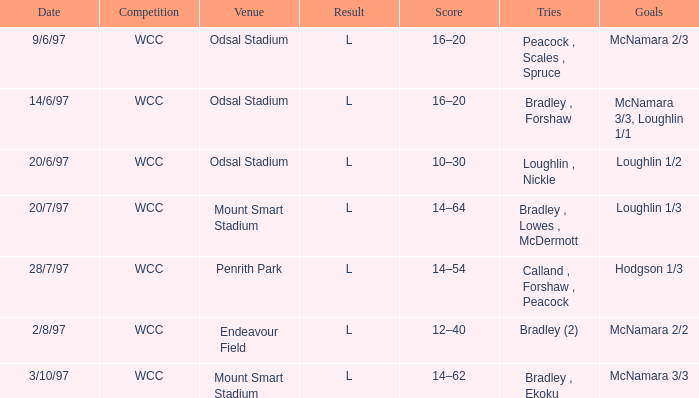Parse the table in full. {'header': ['Date', 'Competition', 'Venue', 'Result', 'Score', 'Tries', 'Goals'], 'rows': [['9/6/97', 'WCC', 'Odsal Stadium', 'L', '16–20', 'Peacock , Scales , Spruce', 'McNamara 2/3'], ['14/6/97', 'WCC', 'Odsal Stadium', 'L', '16–20', 'Bradley , Forshaw', 'McNamara 3/3, Loughlin 1/1'], ['20/6/97', 'WCC', 'Odsal Stadium', 'L', '10–30', 'Loughlin , Nickle', 'Loughlin 1/2'], ['20/7/97', 'WCC', 'Mount Smart Stadium', 'L', '14–64', 'Bradley , Lowes , McDermott', 'Loughlin 1/3'], ['28/7/97', 'WCC', 'Penrith Park', 'L', '14–54', 'Calland , Forshaw , Peacock', 'Hodgson 1/3'], ['2/8/97', 'WCC', 'Endeavour Field', 'L', '12–40', 'Bradley (2)', 'McNamara 2/2'], ['3/10/97', 'WCC', 'Mount Smart Stadium', 'L', '14–62', 'Bradley , Ekoku', 'McNamara 3/3']]} What were the tries on 14/6/97? Bradley , Forshaw. 